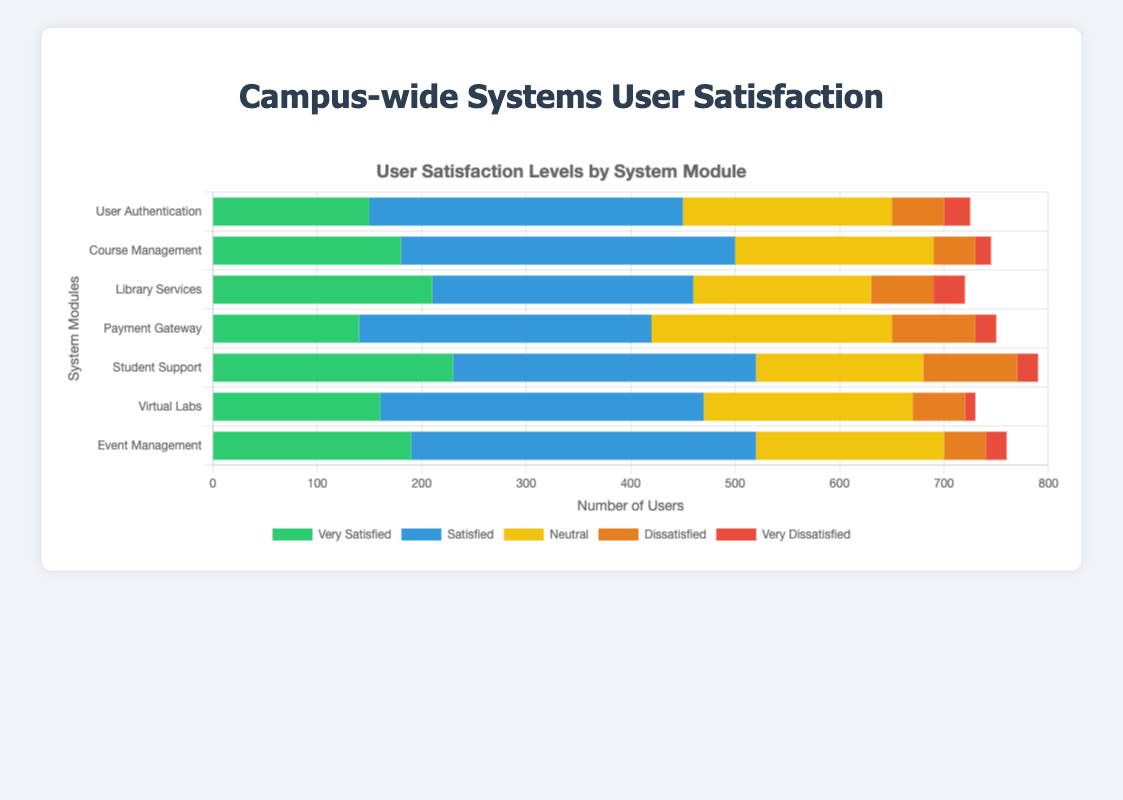Which system module has the highest number of 'Very Satisfied' users? By examining the lengths of the green bars representing 'Very Satisfied' users, we can see that 'Student Support' has the longest green bar.
Answer: Student Support Which system module has the least number of 'Very Dissatisfied' users? By looking at the lengths of the red bars indicating 'Very Dissatisfied' users, it is evident that 'Virtual Labs' has the shortest red bar.
Answer: Virtual Labs What is the total number of satisfied users (both 'Very Satisfied' and 'Satisfied') in 'Library Services'? Sum the values of 'Very Satisfied' (210) and 'Satisfied' (250) for 'Library Services': 210 + 250.
Answer: 460 Are 'Course Management' users generally more satisfied than 'Payment Gateway' users? Compare the sum of 'Very Satisfied' and 'Satisfied' users for both modules: 'Course Management' (180 + 320) has 500 satisfied users, while 'Payment Gateway' (140 + 280) has 420 satisfied users.
Answer: Yes Which two system modules have the same number of 'Dissatisfied' users? By comparing the lengths of the orange bars for 'Dissatisfied' users, 'Course Management' and 'Event Management' both have 40 'Dissatisfied' users.
Answer: Course Management, Event Management Which module has the largest percentage of 'Neutral' users relative to its total user feedback? Calculate the percentage of Neutral users: 'Payment Gateway' has 230 Neutral users out of a total (140 + 280 + 230 + 80 + 20 = 750). The percentage is (230/750)*100 ≈ 30.67%. For other modules, the percentages are lower.
Answer: Payment Gateway Which system module has the highest combined number of 'Dissatisfied' and 'Very Dissatisfied' users? Add the numbers of 'Dissatisfied' and 'Very Dissatisfied' users for each module, and find the highest sum: 'Payment Gateway' has 80 + 20 = 100 users.
Answer: Payment Gateway 